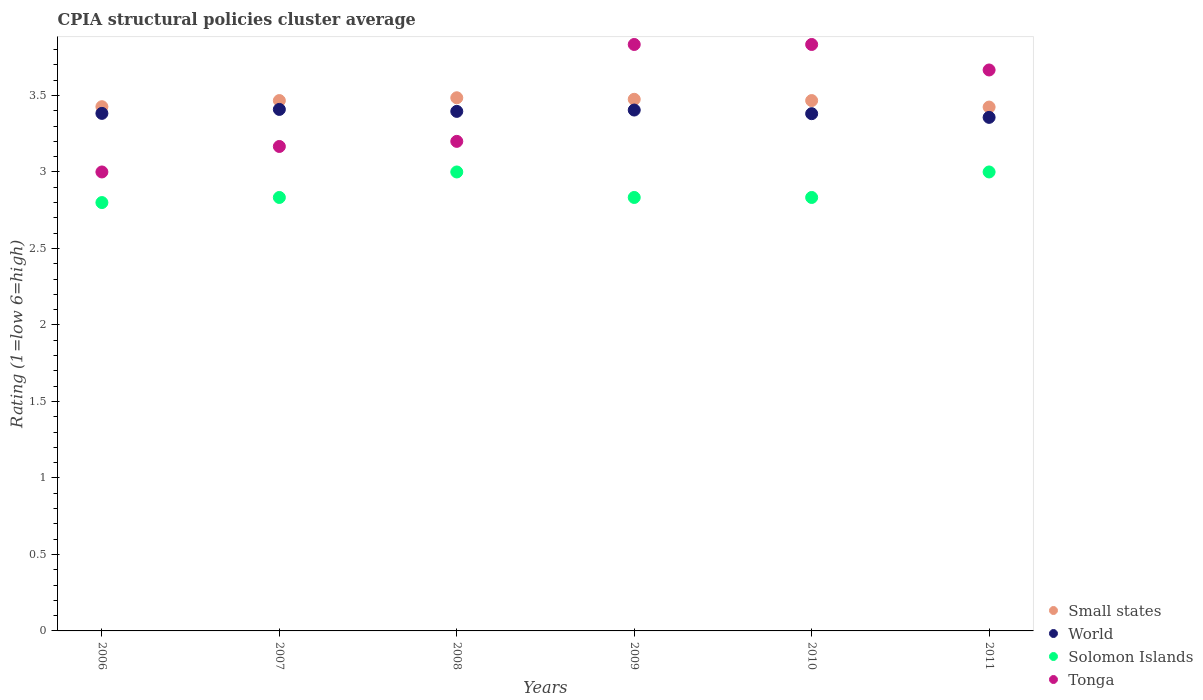How many different coloured dotlines are there?
Ensure brevity in your answer.  4. What is the CPIA rating in World in 2009?
Offer a terse response. 3.4. Across all years, what is the maximum CPIA rating in Small states?
Your answer should be very brief. 3.48. Across all years, what is the minimum CPIA rating in Small states?
Your response must be concise. 3.42. In which year was the CPIA rating in Solomon Islands maximum?
Your response must be concise. 2008. In which year was the CPIA rating in Solomon Islands minimum?
Provide a short and direct response. 2006. What is the total CPIA rating in Small states in the graph?
Your answer should be compact. 20.74. What is the difference between the CPIA rating in Tonga in 2010 and that in 2011?
Give a very brief answer. 0.17. What is the difference between the CPIA rating in Solomon Islands in 2011 and the CPIA rating in World in 2008?
Offer a very short reply. -0.4. What is the average CPIA rating in Solomon Islands per year?
Keep it short and to the point. 2.88. In the year 2008, what is the difference between the CPIA rating in Tonga and CPIA rating in Small states?
Make the answer very short. -0.28. In how many years, is the CPIA rating in Solomon Islands greater than 3.1?
Offer a very short reply. 0. What is the ratio of the CPIA rating in Solomon Islands in 2006 to that in 2008?
Provide a short and direct response. 0.93. Is the CPIA rating in World in 2009 less than that in 2011?
Your answer should be compact. No. Is the difference between the CPIA rating in Tonga in 2007 and 2010 greater than the difference between the CPIA rating in Small states in 2007 and 2010?
Your answer should be compact. No. What is the difference between the highest and the lowest CPIA rating in Solomon Islands?
Your answer should be very brief. 0.2. In how many years, is the CPIA rating in World greater than the average CPIA rating in World taken over all years?
Make the answer very short. 3. Is it the case that in every year, the sum of the CPIA rating in Solomon Islands and CPIA rating in World  is greater than the sum of CPIA rating in Tonga and CPIA rating in Small states?
Your answer should be very brief. No. Is it the case that in every year, the sum of the CPIA rating in Solomon Islands and CPIA rating in Small states  is greater than the CPIA rating in World?
Offer a terse response. Yes. Does the CPIA rating in World monotonically increase over the years?
Your answer should be compact. No. Is the CPIA rating in World strictly less than the CPIA rating in Solomon Islands over the years?
Give a very brief answer. No. How many dotlines are there?
Give a very brief answer. 4. How many years are there in the graph?
Make the answer very short. 6. What is the difference between two consecutive major ticks on the Y-axis?
Ensure brevity in your answer.  0.5. Are the values on the major ticks of Y-axis written in scientific E-notation?
Offer a very short reply. No. Does the graph contain grids?
Offer a very short reply. No. What is the title of the graph?
Offer a very short reply. CPIA structural policies cluster average. Does "Micronesia" appear as one of the legend labels in the graph?
Give a very brief answer. No. What is the label or title of the X-axis?
Your response must be concise. Years. What is the label or title of the Y-axis?
Keep it short and to the point. Rating (1=low 6=high). What is the Rating (1=low 6=high) in Small states in 2006?
Ensure brevity in your answer.  3.43. What is the Rating (1=low 6=high) in World in 2006?
Offer a very short reply. 3.38. What is the Rating (1=low 6=high) in Solomon Islands in 2006?
Provide a succinct answer. 2.8. What is the Rating (1=low 6=high) in Small states in 2007?
Offer a terse response. 3.47. What is the Rating (1=low 6=high) of World in 2007?
Your answer should be very brief. 3.41. What is the Rating (1=low 6=high) of Solomon Islands in 2007?
Your answer should be compact. 2.83. What is the Rating (1=low 6=high) of Tonga in 2007?
Offer a terse response. 3.17. What is the Rating (1=low 6=high) of Small states in 2008?
Offer a very short reply. 3.48. What is the Rating (1=low 6=high) in World in 2008?
Offer a very short reply. 3.4. What is the Rating (1=low 6=high) in Small states in 2009?
Give a very brief answer. 3.48. What is the Rating (1=low 6=high) of World in 2009?
Your response must be concise. 3.4. What is the Rating (1=low 6=high) in Solomon Islands in 2009?
Ensure brevity in your answer.  2.83. What is the Rating (1=low 6=high) of Tonga in 2009?
Give a very brief answer. 3.83. What is the Rating (1=low 6=high) in Small states in 2010?
Keep it short and to the point. 3.47. What is the Rating (1=low 6=high) of World in 2010?
Make the answer very short. 3.38. What is the Rating (1=low 6=high) of Solomon Islands in 2010?
Keep it short and to the point. 2.83. What is the Rating (1=low 6=high) in Tonga in 2010?
Provide a succinct answer. 3.83. What is the Rating (1=low 6=high) in Small states in 2011?
Your answer should be compact. 3.42. What is the Rating (1=low 6=high) in World in 2011?
Ensure brevity in your answer.  3.36. What is the Rating (1=low 6=high) in Tonga in 2011?
Your response must be concise. 3.67. Across all years, what is the maximum Rating (1=low 6=high) in Small states?
Offer a very short reply. 3.48. Across all years, what is the maximum Rating (1=low 6=high) in World?
Your response must be concise. 3.41. Across all years, what is the maximum Rating (1=low 6=high) in Tonga?
Give a very brief answer. 3.83. Across all years, what is the minimum Rating (1=low 6=high) in Small states?
Your response must be concise. 3.42. Across all years, what is the minimum Rating (1=low 6=high) of World?
Offer a very short reply. 3.36. Across all years, what is the minimum Rating (1=low 6=high) in Solomon Islands?
Offer a very short reply. 2.8. Across all years, what is the minimum Rating (1=low 6=high) in Tonga?
Your answer should be compact. 3. What is the total Rating (1=low 6=high) in Small states in the graph?
Provide a succinct answer. 20.74. What is the total Rating (1=low 6=high) of World in the graph?
Offer a terse response. 20.33. What is the total Rating (1=low 6=high) of Solomon Islands in the graph?
Your answer should be very brief. 17.3. What is the total Rating (1=low 6=high) of Tonga in the graph?
Keep it short and to the point. 20.7. What is the difference between the Rating (1=low 6=high) of Small states in 2006 and that in 2007?
Your response must be concise. -0.04. What is the difference between the Rating (1=low 6=high) of World in 2006 and that in 2007?
Your response must be concise. -0.03. What is the difference between the Rating (1=low 6=high) of Solomon Islands in 2006 and that in 2007?
Your answer should be compact. -0.03. What is the difference between the Rating (1=low 6=high) of Small states in 2006 and that in 2008?
Provide a succinct answer. -0.06. What is the difference between the Rating (1=low 6=high) in World in 2006 and that in 2008?
Give a very brief answer. -0.01. What is the difference between the Rating (1=low 6=high) of Small states in 2006 and that in 2009?
Provide a short and direct response. -0.05. What is the difference between the Rating (1=low 6=high) in World in 2006 and that in 2009?
Keep it short and to the point. -0.02. What is the difference between the Rating (1=low 6=high) in Solomon Islands in 2006 and that in 2009?
Ensure brevity in your answer.  -0.03. What is the difference between the Rating (1=low 6=high) in Tonga in 2006 and that in 2009?
Provide a succinct answer. -0.83. What is the difference between the Rating (1=low 6=high) of Small states in 2006 and that in 2010?
Your response must be concise. -0.04. What is the difference between the Rating (1=low 6=high) in World in 2006 and that in 2010?
Make the answer very short. 0. What is the difference between the Rating (1=low 6=high) of Solomon Islands in 2006 and that in 2010?
Offer a very short reply. -0.03. What is the difference between the Rating (1=low 6=high) in Small states in 2006 and that in 2011?
Give a very brief answer. 0. What is the difference between the Rating (1=low 6=high) of World in 2006 and that in 2011?
Offer a terse response. 0.03. What is the difference between the Rating (1=low 6=high) in Tonga in 2006 and that in 2011?
Ensure brevity in your answer.  -0.67. What is the difference between the Rating (1=low 6=high) of Small states in 2007 and that in 2008?
Give a very brief answer. -0.02. What is the difference between the Rating (1=low 6=high) of World in 2007 and that in 2008?
Offer a terse response. 0.01. What is the difference between the Rating (1=low 6=high) of Solomon Islands in 2007 and that in 2008?
Give a very brief answer. -0.17. What is the difference between the Rating (1=low 6=high) in Tonga in 2007 and that in 2008?
Your response must be concise. -0.03. What is the difference between the Rating (1=low 6=high) of Small states in 2007 and that in 2009?
Offer a terse response. -0.01. What is the difference between the Rating (1=low 6=high) of World in 2007 and that in 2009?
Offer a very short reply. 0. What is the difference between the Rating (1=low 6=high) in Tonga in 2007 and that in 2009?
Offer a terse response. -0.67. What is the difference between the Rating (1=low 6=high) of World in 2007 and that in 2010?
Ensure brevity in your answer.  0.03. What is the difference between the Rating (1=low 6=high) of Small states in 2007 and that in 2011?
Your answer should be very brief. 0.04. What is the difference between the Rating (1=low 6=high) in World in 2007 and that in 2011?
Your answer should be compact. 0.05. What is the difference between the Rating (1=low 6=high) of Solomon Islands in 2007 and that in 2011?
Offer a very short reply. -0.17. What is the difference between the Rating (1=low 6=high) of Small states in 2008 and that in 2009?
Your response must be concise. 0.01. What is the difference between the Rating (1=low 6=high) of World in 2008 and that in 2009?
Offer a terse response. -0.01. What is the difference between the Rating (1=low 6=high) in Solomon Islands in 2008 and that in 2009?
Make the answer very short. 0.17. What is the difference between the Rating (1=low 6=high) of Tonga in 2008 and that in 2009?
Make the answer very short. -0.63. What is the difference between the Rating (1=low 6=high) in Small states in 2008 and that in 2010?
Your answer should be compact. 0.02. What is the difference between the Rating (1=low 6=high) of World in 2008 and that in 2010?
Offer a terse response. 0.01. What is the difference between the Rating (1=low 6=high) in Tonga in 2008 and that in 2010?
Offer a terse response. -0.63. What is the difference between the Rating (1=low 6=high) of Small states in 2008 and that in 2011?
Your answer should be compact. 0.06. What is the difference between the Rating (1=low 6=high) in World in 2008 and that in 2011?
Provide a succinct answer. 0.04. What is the difference between the Rating (1=low 6=high) in Solomon Islands in 2008 and that in 2011?
Ensure brevity in your answer.  0. What is the difference between the Rating (1=low 6=high) in Tonga in 2008 and that in 2011?
Give a very brief answer. -0.47. What is the difference between the Rating (1=low 6=high) in Small states in 2009 and that in 2010?
Your response must be concise. 0.01. What is the difference between the Rating (1=low 6=high) in World in 2009 and that in 2010?
Offer a terse response. 0.02. What is the difference between the Rating (1=low 6=high) in Tonga in 2009 and that in 2010?
Offer a terse response. 0. What is the difference between the Rating (1=low 6=high) of Small states in 2009 and that in 2011?
Keep it short and to the point. 0.05. What is the difference between the Rating (1=low 6=high) in World in 2009 and that in 2011?
Your response must be concise. 0.05. What is the difference between the Rating (1=low 6=high) of Solomon Islands in 2009 and that in 2011?
Give a very brief answer. -0.17. What is the difference between the Rating (1=low 6=high) in Tonga in 2009 and that in 2011?
Your response must be concise. 0.17. What is the difference between the Rating (1=low 6=high) of Small states in 2010 and that in 2011?
Your answer should be very brief. 0.04. What is the difference between the Rating (1=low 6=high) in World in 2010 and that in 2011?
Provide a succinct answer. 0.02. What is the difference between the Rating (1=low 6=high) in Tonga in 2010 and that in 2011?
Offer a terse response. 0.17. What is the difference between the Rating (1=low 6=high) in Small states in 2006 and the Rating (1=low 6=high) in World in 2007?
Give a very brief answer. 0.02. What is the difference between the Rating (1=low 6=high) of Small states in 2006 and the Rating (1=low 6=high) of Solomon Islands in 2007?
Provide a succinct answer. 0.59. What is the difference between the Rating (1=low 6=high) in Small states in 2006 and the Rating (1=low 6=high) in Tonga in 2007?
Provide a succinct answer. 0.26. What is the difference between the Rating (1=low 6=high) in World in 2006 and the Rating (1=low 6=high) in Solomon Islands in 2007?
Provide a short and direct response. 0.55. What is the difference between the Rating (1=low 6=high) in World in 2006 and the Rating (1=low 6=high) in Tonga in 2007?
Ensure brevity in your answer.  0.22. What is the difference between the Rating (1=low 6=high) of Solomon Islands in 2006 and the Rating (1=low 6=high) of Tonga in 2007?
Give a very brief answer. -0.37. What is the difference between the Rating (1=low 6=high) in Small states in 2006 and the Rating (1=low 6=high) in World in 2008?
Provide a succinct answer. 0.03. What is the difference between the Rating (1=low 6=high) of Small states in 2006 and the Rating (1=low 6=high) of Solomon Islands in 2008?
Offer a very short reply. 0.43. What is the difference between the Rating (1=low 6=high) of Small states in 2006 and the Rating (1=low 6=high) of Tonga in 2008?
Offer a terse response. 0.23. What is the difference between the Rating (1=low 6=high) of World in 2006 and the Rating (1=low 6=high) of Solomon Islands in 2008?
Your answer should be compact. 0.38. What is the difference between the Rating (1=low 6=high) of World in 2006 and the Rating (1=low 6=high) of Tonga in 2008?
Your answer should be compact. 0.18. What is the difference between the Rating (1=low 6=high) in Small states in 2006 and the Rating (1=low 6=high) in World in 2009?
Give a very brief answer. 0.02. What is the difference between the Rating (1=low 6=high) of Small states in 2006 and the Rating (1=low 6=high) of Solomon Islands in 2009?
Your answer should be very brief. 0.59. What is the difference between the Rating (1=low 6=high) in Small states in 2006 and the Rating (1=low 6=high) in Tonga in 2009?
Keep it short and to the point. -0.41. What is the difference between the Rating (1=low 6=high) in World in 2006 and the Rating (1=low 6=high) in Solomon Islands in 2009?
Offer a terse response. 0.55. What is the difference between the Rating (1=low 6=high) in World in 2006 and the Rating (1=low 6=high) in Tonga in 2009?
Provide a short and direct response. -0.45. What is the difference between the Rating (1=low 6=high) of Solomon Islands in 2006 and the Rating (1=low 6=high) of Tonga in 2009?
Offer a terse response. -1.03. What is the difference between the Rating (1=low 6=high) in Small states in 2006 and the Rating (1=low 6=high) in World in 2010?
Keep it short and to the point. 0.05. What is the difference between the Rating (1=low 6=high) of Small states in 2006 and the Rating (1=low 6=high) of Solomon Islands in 2010?
Your answer should be compact. 0.59. What is the difference between the Rating (1=low 6=high) in Small states in 2006 and the Rating (1=low 6=high) in Tonga in 2010?
Give a very brief answer. -0.41. What is the difference between the Rating (1=low 6=high) in World in 2006 and the Rating (1=low 6=high) in Solomon Islands in 2010?
Ensure brevity in your answer.  0.55. What is the difference between the Rating (1=low 6=high) of World in 2006 and the Rating (1=low 6=high) of Tonga in 2010?
Your answer should be very brief. -0.45. What is the difference between the Rating (1=low 6=high) in Solomon Islands in 2006 and the Rating (1=low 6=high) in Tonga in 2010?
Provide a succinct answer. -1.03. What is the difference between the Rating (1=low 6=high) of Small states in 2006 and the Rating (1=low 6=high) of World in 2011?
Provide a short and direct response. 0.07. What is the difference between the Rating (1=low 6=high) in Small states in 2006 and the Rating (1=low 6=high) in Solomon Islands in 2011?
Your response must be concise. 0.43. What is the difference between the Rating (1=low 6=high) of Small states in 2006 and the Rating (1=low 6=high) of Tonga in 2011?
Keep it short and to the point. -0.24. What is the difference between the Rating (1=low 6=high) in World in 2006 and the Rating (1=low 6=high) in Solomon Islands in 2011?
Provide a short and direct response. 0.38. What is the difference between the Rating (1=low 6=high) in World in 2006 and the Rating (1=low 6=high) in Tonga in 2011?
Offer a very short reply. -0.28. What is the difference between the Rating (1=low 6=high) in Solomon Islands in 2006 and the Rating (1=low 6=high) in Tonga in 2011?
Provide a succinct answer. -0.87. What is the difference between the Rating (1=low 6=high) in Small states in 2007 and the Rating (1=low 6=high) in World in 2008?
Your answer should be compact. 0.07. What is the difference between the Rating (1=low 6=high) in Small states in 2007 and the Rating (1=low 6=high) in Solomon Islands in 2008?
Provide a short and direct response. 0.47. What is the difference between the Rating (1=low 6=high) of Small states in 2007 and the Rating (1=low 6=high) of Tonga in 2008?
Keep it short and to the point. 0.27. What is the difference between the Rating (1=low 6=high) of World in 2007 and the Rating (1=low 6=high) of Solomon Islands in 2008?
Provide a short and direct response. 0.41. What is the difference between the Rating (1=low 6=high) of World in 2007 and the Rating (1=low 6=high) of Tonga in 2008?
Ensure brevity in your answer.  0.21. What is the difference between the Rating (1=low 6=high) in Solomon Islands in 2007 and the Rating (1=low 6=high) in Tonga in 2008?
Ensure brevity in your answer.  -0.37. What is the difference between the Rating (1=low 6=high) in Small states in 2007 and the Rating (1=low 6=high) in World in 2009?
Ensure brevity in your answer.  0.06. What is the difference between the Rating (1=low 6=high) of Small states in 2007 and the Rating (1=low 6=high) of Solomon Islands in 2009?
Your response must be concise. 0.63. What is the difference between the Rating (1=low 6=high) in Small states in 2007 and the Rating (1=low 6=high) in Tonga in 2009?
Provide a short and direct response. -0.37. What is the difference between the Rating (1=low 6=high) in World in 2007 and the Rating (1=low 6=high) in Solomon Islands in 2009?
Provide a short and direct response. 0.58. What is the difference between the Rating (1=low 6=high) of World in 2007 and the Rating (1=low 6=high) of Tonga in 2009?
Keep it short and to the point. -0.42. What is the difference between the Rating (1=low 6=high) of Small states in 2007 and the Rating (1=low 6=high) of World in 2010?
Make the answer very short. 0.09. What is the difference between the Rating (1=low 6=high) in Small states in 2007 and the Rating (1=low 6=high) in Solomon Islands in 2010?
Make the answer very short. 0.63. What is the difference between the Rating (1=low 6=high) of Small states in 2007 and the Rating (1=low 6=high) of Tonga in 2010?
Offer a very short reply. -0.37. What is the difference between the Rating (1=low 6=high) of World in 2007 and the Rating (1=low 6=high) of Solomon Islands in 2010?
Your response must be concise. 0.58. What is the difference between the Rating (1=low 6=high) of World in 2007 and the Rating (1=low 6=high) of Tonga in 2010?
Your response must be concise. -0.42. What is the difference between the Rating (1=low 6=high) in Solomon Islands in 2007 and the Rating (1=low 6=high) in Tonga in 2010?
Give a very brief answer. -1. What is the difference between the Rating (1=low 6=high) of Small states in 2007 and the Rating (1=low 6=high) of World in 2011?
Keep it short and to the point. 0.11. What is the difference between the Rating (1=low 6=high) in Small states in 2007 and the Rating (1=low 6=high) in Solomon Islands in 2011?
Offer a terse response. 0.47. What is the difference between the Rating (1=low 6=high) in World in 2007 and the Rating (1=low 6=high) in Solomon Islands in 2011?
Ensure brevity in your answer.  0.41. What is the difference between the Rating (1=low 6=high) in World in 2007 and the Rating (1=low 6=high) in Tonga in 2011?
Make the answer very short. -0.26. What is the difference between the Rating (1=low 6=high) in Solomon Islands in 2007 and the Rating (1=low 6=high) in Tonga in 2011?
Provide a short and direct response. -0.83. What is the difference between the Rating (1=low 6=high) in Small states in 2008 and the Rating (1=low 6=high) in World in 2009?
Provide a succinct answer. 0.08. What is the difference between the Rating (1=low 6=high) in Small states in 2008 and the Rating (1=low 6=high) in Solomon Islands in 2009?
Your answer should be very brief. 0.65. What is the difference between the Rating (1=low 6=high) in Small states in 2008 and the Rating (1=low 6=high) in Tonga in 2009?
Ensure brevity in your answer.  -0.35. What is the difference between the Rating (1=low 6=high) in World in 2008 and the Rating (1=low 6=high) in Solomon Islands in 2009?
Ensure brevity in your answer.  0.56. What is the difference between the Rating (1=low 6=high) in World in 2008 and the Rating (1=low 6=high) in Tonga in 2009?
Give a very brief answer. -0.44. What is the difference between the Rating (1=low 6=high) of Solomon Islands in 2008 and the Rating (1=low 6=high) of Tonga in 2009?
Offer a terse response. -0.83. What is the difference between the Rating (1=low 6=high) in Small states in 2008 and the Rating (1=low 6=high) in World in 2010?
Ensure brevity in your answer.  0.1. What is the difference between the Rating (1=low 6=high) of Small states in 2008 and the Rating (1=low 6=high) of Solomon Islands in 2010?
Provide a short and direct response. 0.65. What is the difference between the Rating (1=low 6=high) in Small states in 2008 and the Rating (1=low 6=high) in Tonga in 2010?
Ensure brevity in your answer.  -0.35. What is the difference between the Rating (1=low 6=high) in World in 2008 and the Rating (1=low 6=high) in Solomon Islands in 2010?
Your answer should be compact. 0.56. What is the difference between the Rating (1=low 6=high) of World in 2008 and the Rating (1=low 6=high) of Tonga in 2010?
Your response must be concise. -0.44. What is the difference between the Rating (1=low 6=high) in Small states in 2008 and the Rating (1=low 6=high) in World in 2011?
Give a very brief answer. 0.13. What is the difference between the Rating (1=low 6=high) in Small states in 2008 and the Rating (1=low 6=high) in Solomon Islands in 2011?
Give a very brief answer. 0.48. What is the difference between the Rating (1=low 6=high) in Small states in 2008 and the Rating (1=low 6=high) in Tonga in 2011?
Your answer should be very brief. -0.18. What is the difference between the Rating (1=low 6=high) in World in 2008 and the Rating (1=low 6=high) in Solomon Islands in 2011?
Provide a short and direct response. 0.4. What is the difference between the Rating (1=low 6=high) in World in 2008 and the Rating (1=low 6=high) in Tonga in 2011?
Offer a very short reply. -0.27. What is the difference between the Rating (1=low 6=high) of Small states in 2009 and the Rating (1=low 6=high) of World in 2010?
Provide a succinct answer. 0.09. What is the difference between the Rating (1=low 6=high) in Small states in 2009 and the Rating (1=low 6=high) in Solomon Islands in 2010?
Keep it short and to the point. 0.64. What is the difference between the Rating (1=low 6=high) of Small states in 2009 and the Rating (1=low 6=high) of Tonga in 2010?
Keep it short and to the point. -0.36. What is the difference between the Rating (1=low 6=high) of World in 2009 and the Rating (1=low 6=high) of Tonga in 2010?
Give a very brief answer. -0.43. What is the difference between the Rating (1=low 6=high) of Small states in 2009 and the Rating (1=low 6=high) of World in 2011?
Keep it short and to the point. 0.12. What is the difference between the Rating (1=low 6=high) of Small states in 2009 and the Rating (1=low 6=high) of Solomon Islands in 2011?
Keep it short and to the point. 0.47. What is the difference between the Rating (1=low 6=high) of Small states in 2009 and the Rating (1=low 6=high) of Tonga in 2011?
Make the answer very short. -0.19. What is the difference between the Rating (1=low 6=high) of World in 2009 and the Rating (1=low 6=high) of Solomon Islands in 2011?
Your response must be concise. 0.4. What is the difference between the Rating (1=low 6=high) of World in 2009 and the Rating (1=low 6=high) of Tonga in 2011?
Make the answer very short. -0.26. What is the difference between the Rating (1=low 6=high) in Small states in 2010 and the Rating (1=low 6=high) in World in 2011?
Your response must be concise. 0.11. What is the difference between the Rating (1=low 6=high) in Small states in 2010 and the Rating (1=low 6=high) in Solomon Islands in 2011?
Your answer should be compact. 0.47. What is the difference between the Rating (1=low 6=high) of World in 2010 and the Rating (1=low 6=high) of Solomon Islands in 2011?
Ensure brevity in your answer.  0.38. What is the difference between the Rating (1=low 6=high) in World in 2010 and the Rating (1=low 6=high) in Tonga in 2011?
Ensure brevity in your answer.  -0.29. What is the difference between the Rating (1=low 6=high) of Solomon Islands in 2010 and the Rating (1=low 6=high) of Tonga in 2011?
Offer a terse response. -0.83. What is the average Rating (1=low 6=high) of Small states per year?
Give a very brief answer. 3.46. What is the average Rating (1=low 6=high) of World per year?
Give a very brief answer. 3.39. What is the average Rating (1=low 6=high) of Solomon Islands per year?
Offer a terse response. 2.88. What is the average Rating (1=low 6=high) of Tonga per year?
Ensure brevity in your answer.  3.45. In the year 2006, what is the difference between the Rating (1=low 6=high) of Small states and Rating (1=low 6=high) of World?
Provide a short and direct response. 0.04. In the year 2006, what is the difference between the Rating (1=low 6=high) in Small states and Rating (1=low 6=high) in Solomon Islands?
Ensure brevity in your answer.  0.63. In the year 2006, what is the difference between the Rating (1=low 6=high) of Small states and Rating (1=low 6=high) of Tonga?
Your response must be concise. 0.43. In the year 2006, what is the difference between the Rating (1=low 6=high) in World and Rating (1=low 6=high) in Solomon Islands?
Make the answer very short. 0.58. In the year 2006, what is the difference between the Rating (1=low 6=high) of World and Rating (1=low 6=high) of Tonga?
Offer a terse response. 0.38. In the year 2007, what is the difference between the Rating (1=low 6=high) of Small states and Rating (1=low 6=high) of World?
Make the answer very short. 0.06. In the year 2007, what is the difference between the Rating (1=low 6=high) of Small states and Rating (1=low 6=high) of Solomon Islands?
Provide a succinct answer. 0.63. In the year 2007, what is the difference between the Rating (1=low 6=high) of Small states and Rating (1=low 6=high) of Tonga?
Provide a short and direct response. 0.3. In the year 2007, what is the difference between the Rating (1=low 6=high) of World and Rating (1=low 6=high) of Solomon Islands?
Keep it short and to the point. 0.58. In the year 2007, what is the difference between the Rating (1=low 6=high) in World and Rating (1=low 6=high) in Tonga?
Your response must be concise. 0.24. In the year 2007, what is the difference between the Rating (1=low 6=high) of Solomon Islands and Rating (1=low 6=high) of Tonga?
Your answer should be compact. -0.33. In the year 2008, what is the difference between the Rating (1=low 6=high) of Small states and Rating (1=low 6=high) of World?
Your response must be concise. 0.09. In the year 2008, what is the difference between the Rating (1=low 6=high) of Small states and Rating (1=low 6=high) of Solomon Islands?
Offer a terse response. 0.48. In the year 2008, what is the difference between the Rating (1=low 6=high) of Small states and Rating (1=low 6=high) of Tonga?
Offer a very short reply. 0.28. In the year 2008, what is the difference between the Rating (1=low 6=high) in World and Rating (1=low 6=high) in Solomon Islands?
Offer a very short reply. 0.4. In the year 2008, what is the difference between the Rating (1=low 6=high) in World and Rating (1=low 6=high) in Tonga?
Your answer should be very brief. 0.2. In the year 2008, what is the difference between the Rating (1=low 6=high) of Solomon Islands and Rating (1=low 6=high) of Tonga?
Provide a short and direct response. -0.2. In the year 2009, what is the difference between the Rating (1=low 6=high) of Small states and Rating (1=low 6=high) of World?
Provide a short and direct response. 0.07. In the year 2009, what is the difference between the Rating (1=low 6=high) of Small states and Rating (1=low 6=high) of Solomon Islands?
Your answer should be compact. 0.64. In the year 2009, what is the difference between the Rating (1=low 6=high) in Small states and Rating (1=low 6=high) in Tonga?
Your answer should be compact. -0.36. In the year 2009, what is the difference between the Rating (1=low 6=high) of World and Rating (1=low 6=high) of Tonga?
Provide a short and direct response. -0.43. In the year 2009, what is the difference between the Rating (1=low 6=high) of Solomon Islands and Rating (1=low 6=high) of Tonga?
Your response must be concise. -1. In the year 2010, what is the difference between the Rating (1=low 6=high) in Small states and Rating (1=low 6=high) in World?
Your response must be concise. 0.09. In the year 2010, what is the difference between the Rating (1=low 6=high) in Small states and Rating (1=low 6=high) in Solomon Islands?
Offer a terse response. 0.63. In the year 2010, what is the difference between the Rating (1=low 6=high) in Small states and Rating (1=low 6=high) in Tonga?
Ensure brevity in your answer.  -0.37. In the year 2010, what is the difference between the Rating (1=low 6=high) in World and Rating (1=low 6=high) in Solomon Islands?
Provide a succinct answer. 0.55. In the year 2010, what is the difference between the Rating (1=low 6=high) in World and Rating (1=low 6=high) in Tonga?
Your answer should be compact. -0.45. In the year 2011, what is the difference between the Rating (1=low 6=high) of Small states and Rating (1=low 6=high) of World?
Provide a short and direct response. 0.07. In the year 2011, what is the difference between the Rating (1=low 6=high) in Small states and Rating (1=low 6=high) in Solomon Islands?
Give a very brief answer. 0.42. In the year 2011, what is the difference between the Rating (1=low 6=high) in Small states and Rating (1=low 6=high) in Tonga?
Provide a succinct answer. -0.24. In the year 2011, what is the difference between the Rating (1=low 6=high) in World and Rating (1=low 6=high) in Solomon Islands?
Offer a terse response. 0.36. In the year 2011, what is the difference between the Rating (1=low 6=high) in World and Rating (1=low 6=high) in Tonga?
Your answer should be very brief. -0.31. What is the ratio of the Rating (1=low 6=high) in Small states in 2006 to that in 2007?
Your answer should be compact. 0.99. What is the ratio of the Rating (1=low 6=high) in World in 2006 to that in 2007?
Offer a terse response. 0.99. What is the ratio of the Rating (1=low 6=high) in Solomon Islands in 2006 to that in 2007?
Offer a very short reply. 0.99. What is the ratio of the Rating (1=low 6=high) in Small states in 2006 to that in 2008?
Your response must be concise. 0.98. What is the ratio of the Rating (1=low 6=high) of Small states in 2006 to that in 2009?
Your answer should be very brief. 0.99. What is the ratio of the Rating (1=low 6=high) in World in 2006 to that in 2009?
Make the answer very short. 0.99. What is the ratio of the Rating (1=low 6=high) in Solomon Islands in 2006 to that in 2009?
Give a very brief answer. 0.99. What is the ratio of the Rating (1=low 6=high) of Tonga in 2006 to that in 2009?
Your answer should be compact. 0.78. What is the ratio of the Rating (1=low 6=high) in Tonga in 2006 to that in 2010?
Your response must be concise. 0.78. What is the ratio of the Rating (1=low 6=high) in Small states in 2006 to that in 2011?
Make the answer very short. 1. What is the ratio of the Rating (1=low 6=high) in World in 2006 to that in 2011?
Offer a terse response. 1.01. What is the ratio of the Rating (1=low 6=high) of Tonga in 2006 to that in 2011?
Make the answer very short. 0.82. What is the ratio of the Rating (1=low 6=high) in World in 2007 to that in 2008?
Ensure brevity in your answer.  1. What is the ratio of the Rating (1=low 6=high) of Tonga in 2007 to that in 2008?
Make the answer very short. 0.99. What is the ratio of the Rating (1=low 6=high) of Small states in 2007 to that in 2009?
Your response must be concise. 1. What is the ratio of the Rating (1=low 6=high) in Tonga in 2007 to that in 2009?
Your answer should be very brief. 0.83. What is the ratio of the Rating (1=low 6=high) of World in 2007 to that in 2010?
Provide a succinct answer. 1.01. What is the ratio of the Rating (1=low 6=high) in Tonga in 2007 to that in 2010?
Provide a succinct answer. 0.83. What is the ratio of the Rating (1=low 6=high) of Small states in 2007 to that in 2011?
Ensure brevity in your answer.  1.01. What is the ratio of the Rating (1=low 6=high) in World in 2007 to that in 2011?
Offer a very short reply. 1.02. What is the ratio of the Rating (1=low 6=high) in Tonga in 2007 to that in 2011?
Your answer should be very brief. 0.86. What is the ratio of the Rating (1=low 6=high) in Small states in 2008 to that in 2009?
Offer a terse response. 1. What is the ratio of the Rating (1=low 6=high) of World in 2008 to that in 2009?
Provide a succinct answer. 1. What is the ratio of the Rating (1=low 6=high) in Solomon Islands in 2008 to that in 2009?
Ensure brevity in your answer.  1.06. What is the ratio of the Rating (1=low 6=high) of Tonga in 2008 to that in 2009?
Give a very brief answer. 0.83. What is the ratio of the Rating (1=low 6=high) of World in 2008 to that in 2010?
Provide a succinct answer. 1. What is the ratio of the Rating (1=low 6=high) in Solomon Islands in 2008 to that in 2010?
Keep it short and to the point. 1.06. What is the ratio of the Rating (1=low 6=high) of Tonga in 2008 to that in 2010?
Your response must be concise. 0.83. What is the ratio of the Rating (1=low 6=high) in Small states in 2008 to that in 2011?
Provide a succinct answer. 1.02. What is the ratio of the Rating (1=low 6=high) in World in 2008 to that in 2011?
Keep it short and to the point. 1.01. What is the ratio of the Rating (1=low 6=high) of Tonga in 2008 to that in 2011?
Provide a succinct answer. 0.87. What is the ratio of the Rating (1=low 6=high) in World in 2009 to that in 2010?
Offer a very short reply. 1.01. What is the ratio of the Rating (1=low 6=high) in Small states in 2009 to that in 2011?
Provide a succinct answer. 1.01. What is the ratio of the Rating (1=low 6=high) in World in 2009 to that in 2011?
Make the answer very short. 1.01. What is the ratio of the Rating (1=low 6=high) in Solomon Islands in 2009 to that in 2011?
Keep it short and to the point. 0.94. What is the ratio of the Rating (1=low 6=high) of Tonga in 2009 to that in 2011?
Provide a succinct answer. 1.05. What is the ratio of the Rating (1=low 6=high) of Small states in 2010 to that in 2011?
Your answer should be very brief. 1.01. What is the ratio of the Rating (1=low 6=high) in World in 2010 to that in 2011?
Offer a terse response. 1.01. What is the ratio of the Rating (1=low 6=high) of Solomon Islands in 2010 to that in 2011?
Keep it short and to the point. 0.94. What is the ratio of the Rating (1=low 6=high) in Tonga in 2010 to that in 2011?
Your answer should be compact. 1.05. What is the difference between the highest and the second highest Rating (1=low 6=high) in World?
Give a very brief answer. 0. What is the difference between the highest and the second highest Rating (1=low 6=high) of Solomon Islands?
Give a very brief answer. 0. What is the difference between the highest and the lowest Rating (1=low 6=high) of Small states?
Keep it short and to the point. 0.06. What is the difference between the highest and the lowest Rating (1=low 6=high) in World?
Offer a terse response. 0.05. What is the difference between the highest and the lowest Rating (1=low 6=high) in Solomon Islands?
Your answer should be very brief. 0.2. 